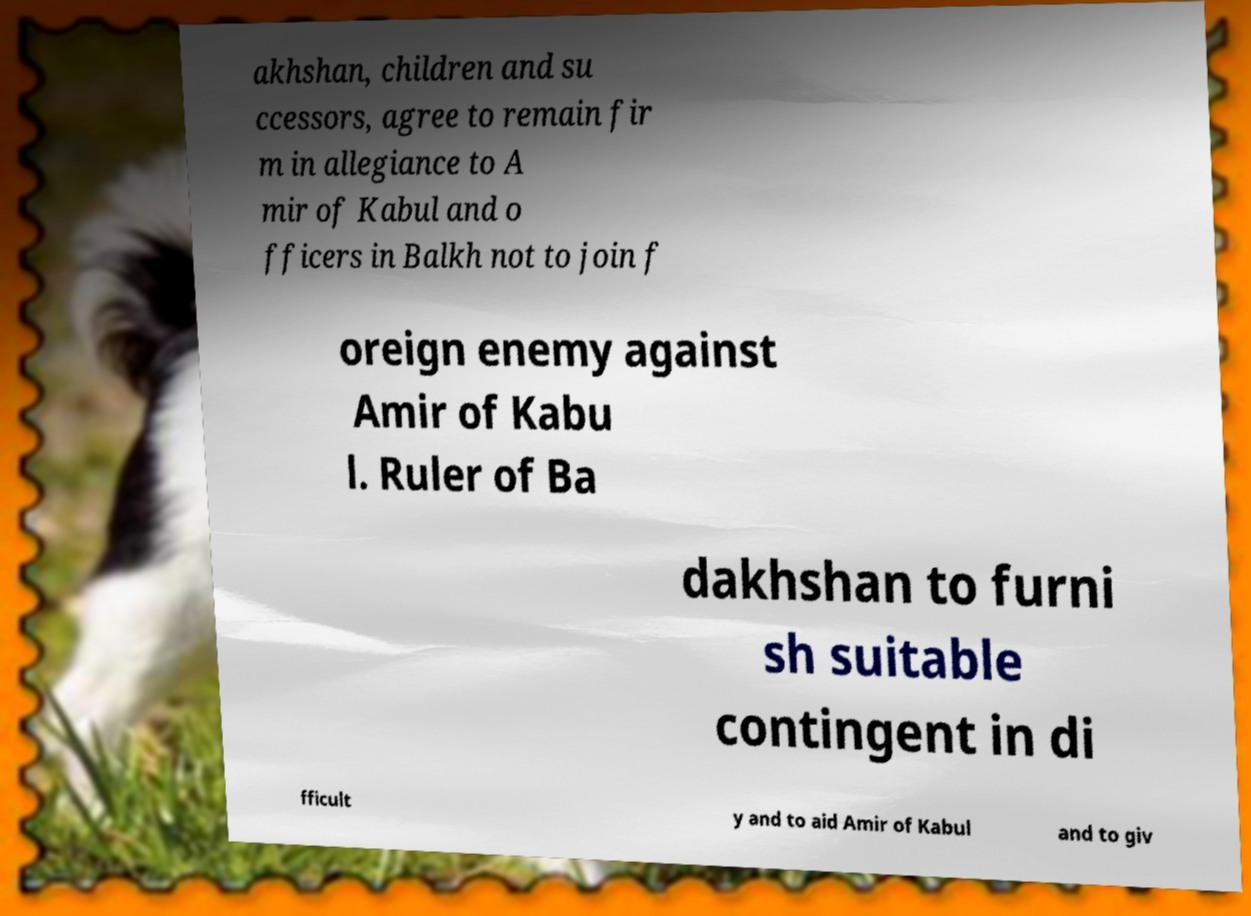For documentation purposes, I need the text within this image transcribed. Could you provide that? akhshan, children and su ccessors, agree to remain fir m in allegiance to A mir of Kabul and o fficers in Balkh not to join f oreign enemy against Amir of Kabu l. Ruler of Ba dakhshan to furni sh suitable contingent in di fficult y and to aid Amir of Kabul and to giv 